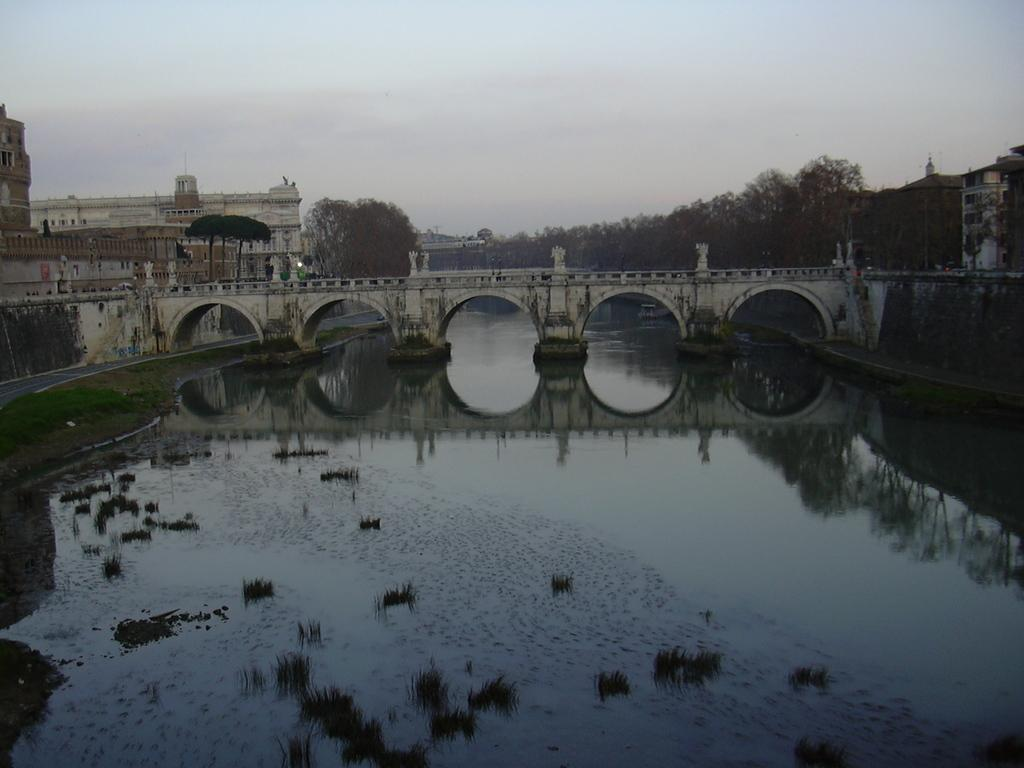What is the main feature of the image? There is water in the image. What is built over the water? There is a bridge over the water. What can be seen in the background of the image? There are trees in the background of the image. What type of structures are visible in the image? There are buildings visible in the image. What is visible at the top of the image? The sky is visible at the top of the image. 